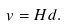Convert formula to latex. <formula><loc_0><loc_0><loc_500><loc_500>v = H d .</formula> 